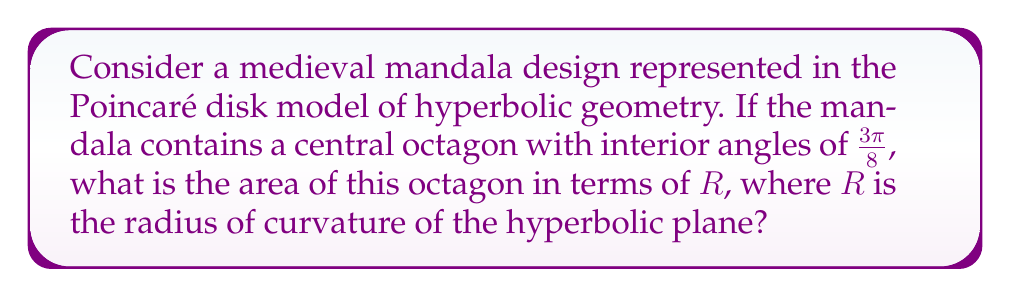Teach me how to tackle this problem. Let's approach this step-by-step:

1) In hyperbolic geometry, the area of a regular polygon is given by the formula:

   $$A = (n-2)\pi - \sum_{i=1}^n \theta_i$$

   where $n$ is the number of sides and $\theta_i$ are the interior angles.

2) For our octagon, $n = 8$ and each interior angle $\theta_i = \frac{3\pi}{8}$.

3) Substituting these values:

   $$A = (8-2)\pi - 8 \cdot \frac{3\pi}{8}$$

4) Simplifying:

   $$A = 6\pi - 3\pi = 3\pi$$

5) However, this result is in terms of the hyperbolic plane with curvature $-1$. To express it in terms of a plane with radius of curvature $R$, we need to multiply by $R^2$:

   $$A = 3\pi R^2$$

6) This formula gives the area of the octagon in the hyperbolic plane. In the Poincaré disk model, areas are distorted, but the hyperbolic area remains the same.

[asy]
import geometry;

unitsize(50);
draw(circle((0,0),1), rgb(0,0,1));
pair[] vertices = {dir(0), dir(45), dir(90), dir(135), dir(180), dir(225), dir(270), dir(315)};
for(int i = 0; i < 8; ++i) {
  draw(vertices[i]--vertices[(i+1)%8], rgb(1,0,0));
}
label("$R$", (0.5,0), E);
[/asy]

The figure above illustrates the octagon in the Poincaré disk model. The red octagon represents the mandala's central shape, while the blue circle represents the boundary of the hyperbolic plane.
Answer: $3\pi R^2$ 